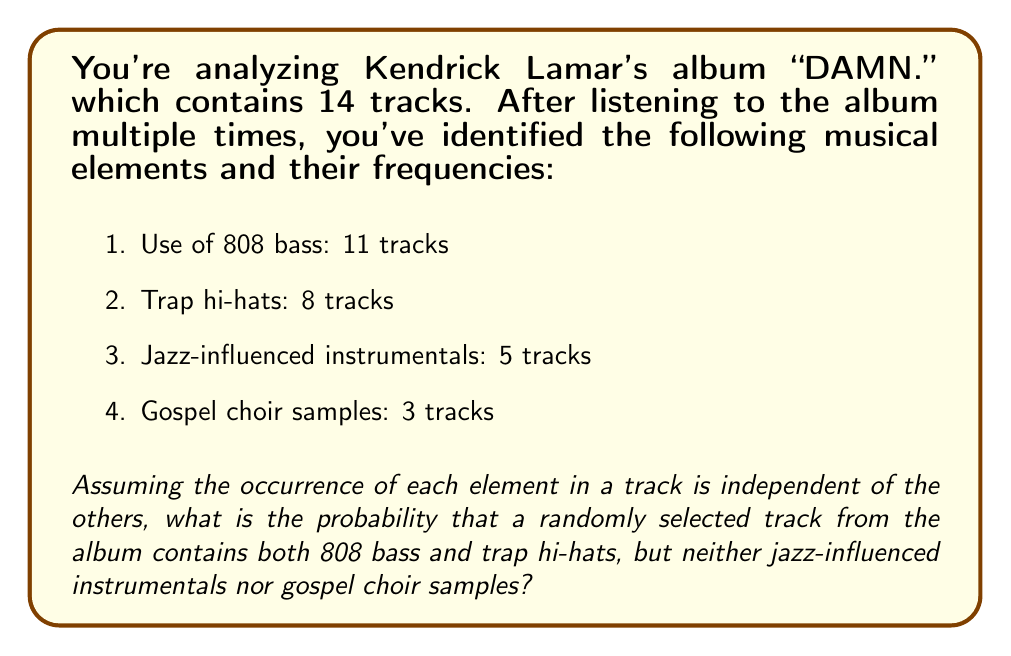Can you answer this question? Let's approach this step-by-step using probability theory:

1) First, we need to calculate the probability of each element occurring in a randomly selected track:

   $P(808) = \frac{11}{14}$
   $P(Hi-hats) = \frac{8}{14}$
   $P(Jazz) = \frac{5}{14}$
   $P(Gospel) = \frac{3}{14}$

2) The question asks for the probability of a track having 808 bass AND trap hi-hats, but NOT jazz instrumentals AND NOT gospel samples. We can express this as:

   $P(808 \cap Hi-hats \cap Jazz^c \cap Gospel^c)$

   Where $^c$ denotes the complement (not occurring).

3) Since we're assuming independence, we can multiply these probabilities:

   $P(808) \times P(Hi-hats) \times P(Jazz^c) \times P(Gospel^c)$

4) We already have $P(808)$ and $P(Hi-hats)$. For $P(Jazz^c)$ and $P(Gospel^c)$, we use the complement rule: $P(A^c) = 1 - P(A)$

   $P(Jazz^c) = 1 - \frac{5}{14} = \frac{9}{14}$
   $P(Gospel^c) = 1 - \frac{3}{14} = \frac{11}{14}$

5) Now we can multiply all these probabilities:

   $$\frac{11}{14} \times \frac{8}{14} \times \frac{9}{14} \times \frac{11}{14} = \frac{8712}{38416} \approx 0.2268$$

6) Therefore, the probability is approximately 0.2268 or about 22.68%.
Answer: $\frac{8712}{38416}$ or approximately 0.2268 